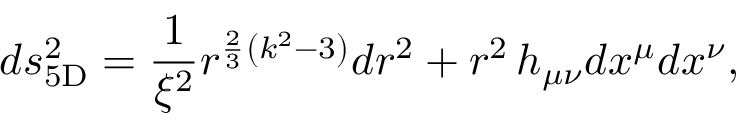Convert formula to latex. <formula><loc_0><loc_0><loc_500><loc_500>d s _ { 5 D } ^ { 2 } = { \frac { 1 } { \xi ^ { 2 } } } r ^ { { \frac { 2 } { 3 } } \left ( k ^ { 2 } - 3 \right ) } d r ^ { 2 } + r ^ { 2 } \, h _ { \mu \nu } d x ^ { \mu } d x ^ { \nu } ,</formula> 